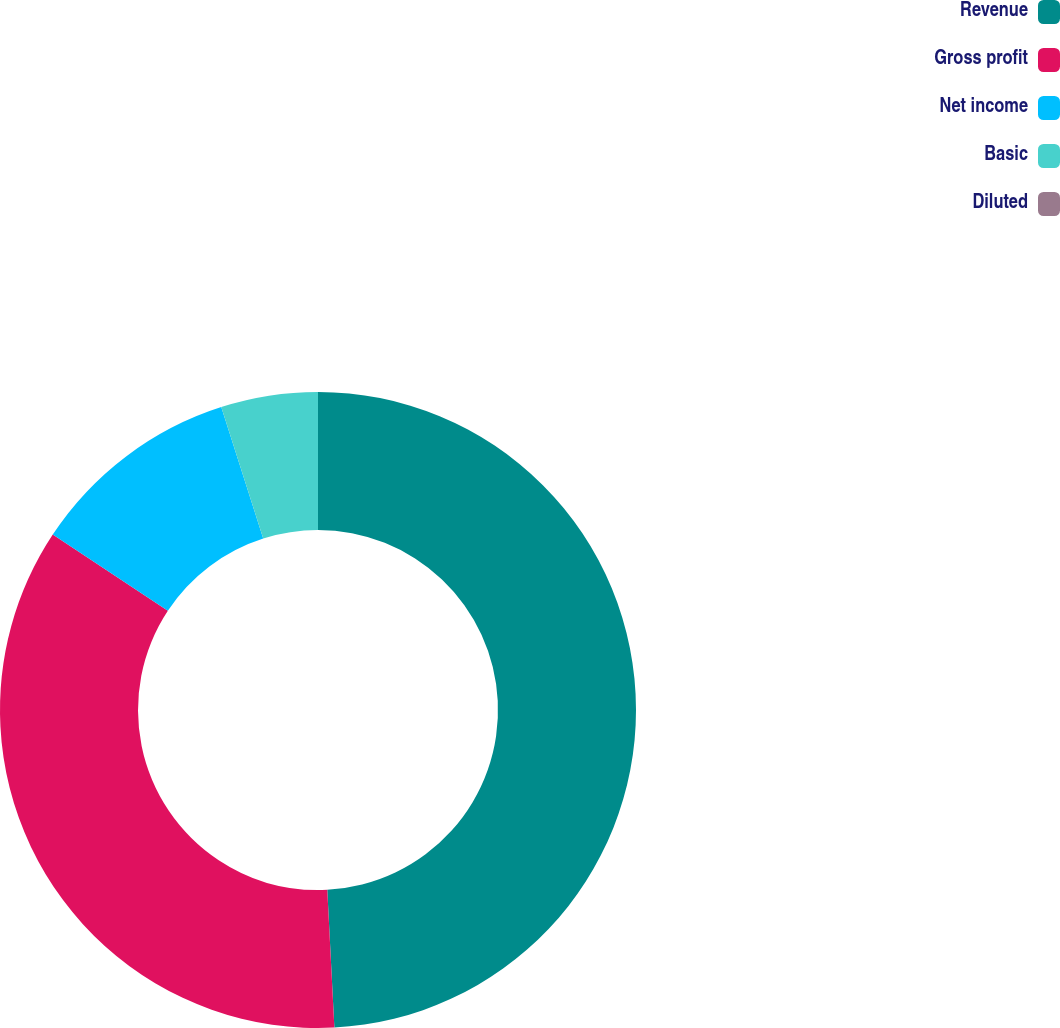Convert chart. <chart><loc_0><loc_0><loc_500><loc_500><pie_chart><fcel>Revenue<fcel>Gross profit<fcel>Net income<fcel>Basic<fcel>Diluted<nl><fcel>49.18%<fcel>35.12%<fcel>10.78%<fcel>4.92%<fcel>0.0%<nl></chart> 